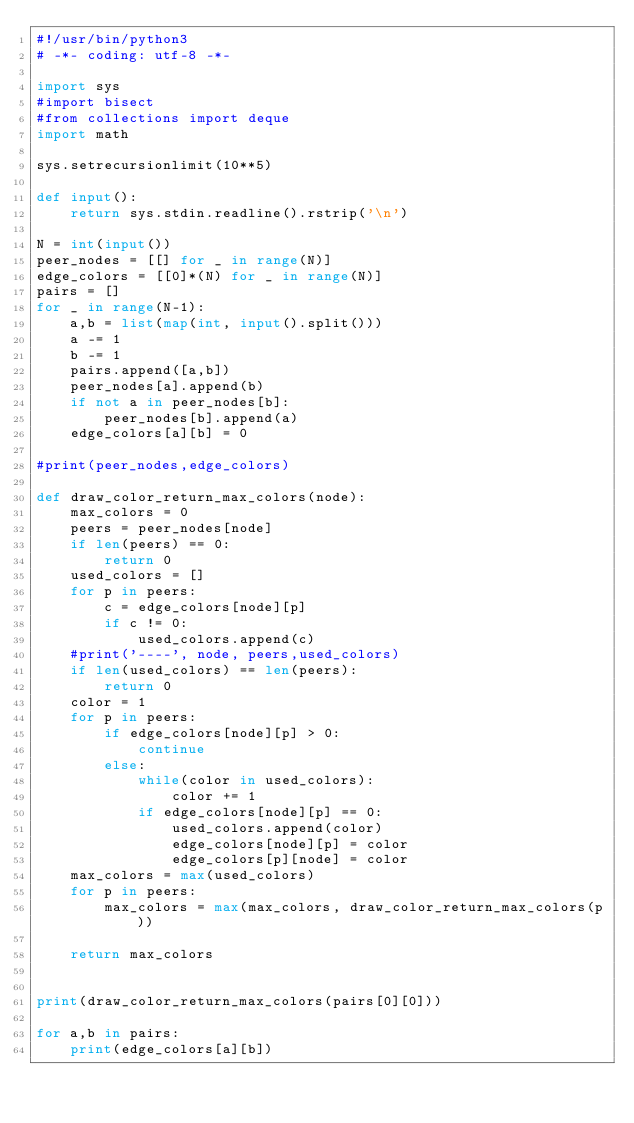Convert code to text. <code><loc_0><loc_0><loc_500><loc_500><_Python_>#!/usr/bin/python3
# -*- coding: utf-8 -*-

import sys
#import bisect
#from collections import deque
import math

sys.setrecursionlimit(10**5)

def input():
    return sys.stdin.readline().rstrip('\n')

N = int(input())
peer_nodes = [[] for _ in range(N)]
edge_colors = [[0]*(N) for _ in range(N)]
pairs = []
for _ in range(N-1):
    a,b = list(map(int, input().split()))
    a -= 1
    b -= 1
    pairs.append([a,b])
    peer_nodes[a].append(b)
    if not a in peer_nodes[b]:
        peer_nodes[b].append(a)
    edge_colors[a][b] = 0

#print(peer_nodes,edge_colors)

def draw_color_return_max_colors(node):
    max_colors = 0
    peers = peer_nodes[node]
    if len(peers) == 0:
        return 0
    used_colors = []
    for p in peers:
        c = edge_colors[node][p]
        if c != 0:
            used_colors.append(c)
    #print('----', node, peers,used_colors)
    if len(used_colors) == len(peers):
        return 0
    color = 1
    for p in peers:
        if edge_colors[node][p] > 0:
            continue
        else:
            while(color in used_colors):
                color += 1
            if edge_colors[node][p] == 0:
                used_colors.append(color)
                edge_colors[node][p] = color
                edge_colors[p][node] = color
    max_colors = max(used_colors)
    for p in peers:
        max_colors = max(max_colors, draw_color_return_max_colors(p))

    return max_colors


print(draw_color_return_max_colors(pairs[0][0]))

for a,b in pairs:
    print(edge_colors[a][b])
</code> 